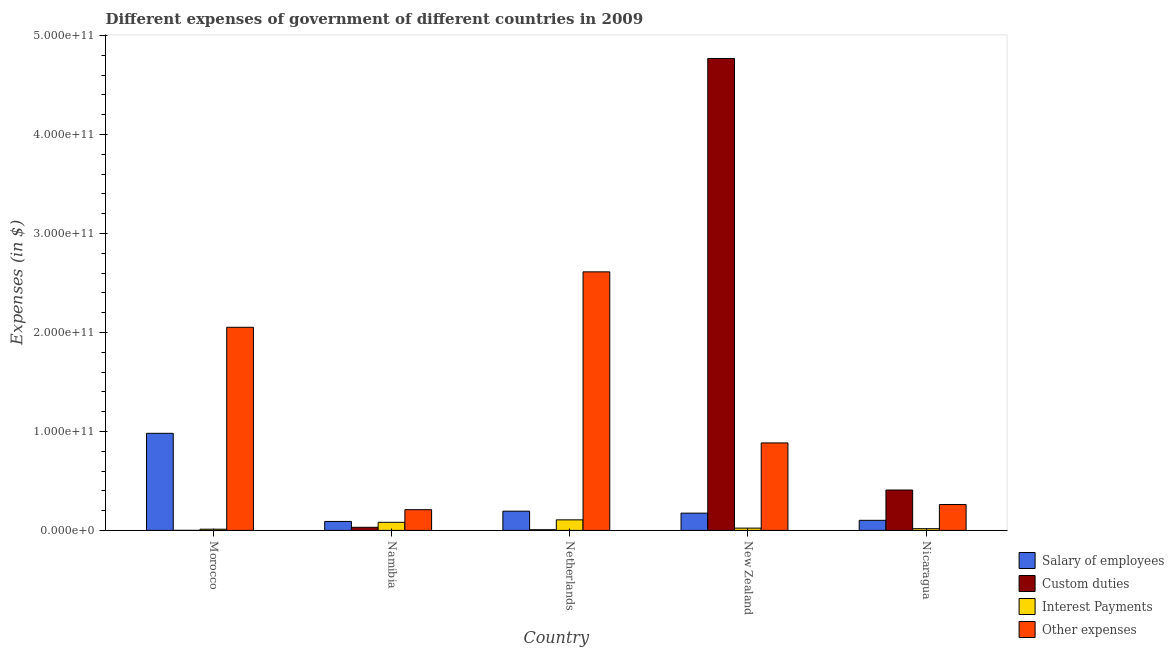How many different coloured bars are there?
Provide a short and direct response. 4. How many groups of bars are there?
Offer a terse response. 5. Are the number of bars per tick equal to the number of legend labels?
Keep it short and to the point. Yes. What is the label of the 2nd group of bars from the left?
Ensure brevity in your answer.  Namibia. In how many cases, is the number of bars for a given country not equal to the number of legend labels?
Give a very brief answer. 0. What is the amount spent on salary of employees in New Zealand?
Keep it short and to the point. 1.74e+1. Across all countries, what is the maximum amount spent on salary of employees?
Provide a succinct answer. 9.81e+1. Across all countries, what is the minimum amount spent on custom duties?
Keep it short and to the point. 9.90e+05. In which country was the amount spent on salary of employees maximum?
Provide a short and direct response. Morocco. In which country was the amount spent on other expenses minimum?
Offer a very short reply. Namibia. What is the total amount spent on custom duties in the graph?
Make the answer very short. 5.21e+11. What is the difference between the amount spent on custom duties in Netherlands and that in New Zealand?
Offer a terse response. -4.76e+11. What is the difference between the amount spent on other expenses in New Zealand and the amount spent on salary of employees in Namibia?
Keep it short and to the point. 7.93e+1. What is the average amount spent on other expenses per country?
Offer a very short reply. 1.20e+11. What is the difference between the amount spent on interest payments and amount spent on salary of employees in Netherlands?
Your answer should be very brief. -8.78e+09. What is the ratio of the amount spent on interest payments in Morocco to that in New Zealand?
Provide a short and direct response. 0.52. What is the difference between the highest and the second highest amount spent on interest payments?
Give a very brief answer. 2.49e+09. What is the difference between the highest and the lowest amount spent on interest payments?
Your answer should be compact. 9.45e+09. Is the sum of the amount spent on interest payments in Namibia and New Zealand greater than the maximum amount spent on other expenses across all countries?
Give a very brief answer. No. Is it the case that in every country, the sum of the amount spent on interest payments and amount spent on salary of employees is greater than the sum of amount spent on other expenses and amount spent on custom duties?
Your answer should be very brief. No. What does the 2nd bar from the left in Nicaragua represents?
Ensure brevity in your answer.  Custom duties. What does the 4th bar from the right in Nicaragua represents?
Offer a very short reply. Salary of employees. Are all the bars in the graph horizontal?
Provide a short and direct response. No. How many countries are there in the graph?
Offer a very short reply. 5. What is the difference between two consecutive major ticks on the Y-axis?
Your answer should be compact. 1.00e+11. Does the graph contain any zero values?
Your answer should be compact. No. Does the graph contain grids?
Your answer should be compact. No. Where does the legend appear in the graph?
Provide a succinct answer. Bottom right. How many legend labels are there?
Provide a succinct answer. 4. How are the legend labels stacked?
Give a very brief answer. Vertical. What is the title of the graph?
Make the answer very short. Different expenses of government of different countries in 2009. What is the label or title of the Y-axis?
Ensure brevity in your answer.  Expenses (in $). What is the Expenses (in $) of Salary of employees in Morocco?
Keep it short and to the point. 9.81e+1. What is the Expenses (in $) in Custom duties in Morocco?
Ensure brevity in your answer.  9.90e+05. What is the Expenses (in $) of Interest Payments in Morocco?
Offer a terse response. 1.20e+09. What is the Expenses (in $) in Other expenses in Morocco?
Offer a terse response. 2.05e+11. What is the Expenses (in $) of Salary of employees in Namibia?
Make the answer very short. 9.05e+09. What is the Expenses (in $) in Custom duties in Namibia?
Offer a very short reply. 3.11e+09. What is the Expenses (in $) in Interest Payments in Namibia?
Give a very brief answer. 8.15e+09. What is the Expenses (in $) of Other expenses in Namibia?
Your answer should be compact. 2.09e+1. What is the Expenses (in $) in Salary of employees in Netherlands?
Make the answer very short. 1.94e+1. What is the Expenses (in $) of Custom duties in Netherlands?
Your answer should be very brief. 6.50e+08. What is the Expenses (in $) of Interest Payments in Netherlands?
Give a very brief answer. 1.06e+1. What is the Expenses (in $) of Other expenses in Netherlands?
Ensure brevity in your answer.  2.61e+11. What is the Expenses (in $) in Salary of employees in New Zealand?
Your answer should be compact. 1.74e+1. What is the Expenses (in $) of Custom duties in New Zealand?
Offer a very short reply. 4.77e+11. What is the Expenses (in $) in Interest Payments in New Zealand?
Offer a very short reply. 2.30e+09. What is the Expenses (in $) of Other expenses in New Zealand?
Your answer should be very brief. 8.84e+1. What is the Expenses (in $) in Salary of employees in Nicaragua?
Keep it short and to the point. 1.02e+1. What is the Expenses (in $) in Custom duties in Nicaragua?
Offer a terse response. 4.08e+1. What is the Expenses (in $) in Interest Payments in Nicaragua?
Offer a very short reply. 1.71e+09. What is the Expenses (in $) of Other expenses in Nicaragua?
Provide a succinct answer. 2.62e+1. Across all countries, what is the maximum Expenses (in $) of Salary of employees?
Keep it short and to the point. 9.81e+1. Across all countries, what is the maximum Expenses (in $) in Custom duties?
Keep it short and to the point. 4.77e+11. Across all countries, what is the maximum Expenses (in $) of Interest Payments?
Your answer should be very brief. 1.06e+1. Across all countries, what is the maximum Expenses (in $) of Other expenses?
Your answer should be compact. 2.61e+11. Across all countries, what is the minimum Expenses (in $) in Salary of employees?
Make the answer very short. 9.05e+09. Across all countries, what is the minimum Expenses (in $) in Custom duties?
Give a very brief answer. 9.90e+05. Across all countries, what is the minimum Expenses (in $) in Interest Payments?
Your answer should be very brief. 1.20e+09. Across all countries, what is the minimum Expenses (in $) in Other expenses?
Offer a terse response. 2.09e+1. What is the total Expenses (in $) in Salary of employees in the graph?
Keep it short and to the point. 1.54e+11. What is the total Expenses (in $) in Custom duties in the graph?
Provide a short and direct response. 5.21e+11. What is the total Expenses (in $) of Interest Payments in the graph?
Your response must be concise. 2.40e+1. What is the total Expenses (in $) in Other expenses in the graph?
Keep it short and to the point. 6.02e+11. What is the difference between the Expenses (in $) of Salary of employees in Morocco and that in Namibia?
Keep it short and to the point. 8.90e+1. What is the difference between the Expenses (in $) of Custom duties in Morocco and that in Namibia?
Offer a very short reply. -3.11e+09. What is the difference between the Expenses (in $) of Interest Payments in Morocco and that in Namibia?
Provide a short and direct response. -6.96e+09. What is the difference between the Expenses (in $) in Other expenses in Morocco and that in Namibia?
Make the answer very short. 1.84e+11. What is the difference between the Expenses (in $) of Salary of employees in Morocco and that in Netherlands?
Your answer should be compact. 7.87e+1. What is the difference between the Expenses (in $) in Custom duties in Morocco and that in Netherlands?
Provide a short and direct response. -6.49e+08. What is the difference between the Expenses (in $) in Interest Payments in Morocco and that in Netherlands?
Offer a very short reply. -9.45e+09. What is the difference between the Expenses (in $) in Other expenses in Morocco and that in Netherlands?
Your answer should be very brief. -5.60e+1. What is the difference between the Expenses (in $) in Salary of employees in Morocco and that in New Zealand?
Offer a very short reply. 8.07e+1. What is the difference between the Expenses (in $) of Custom duties in Morocco and that in New Zealand?
Provide a short and direct response. -4.77e+11. What is the difference between the Expenses (in $) of Interest Payments in Morocco and that in New Zealand?
Ensure brevity in your answer.  -1.10e+09. What is the difference between the Expenses (in $) in Other expenses in Morocco and that in New Zealand?
Your response must be concise. 1.17e+11. What is the difference between the Expenses (in $) in Salary of employees in Morocco and that in Nicaragua?
Your answer should be very brief. 8.79e+1. What is the difference between the Expenses (in $) of Custom duties in Morocco and that in Nicaragua?
Give a very brief answer. -4.08e+1. What is the difference between the Expenses (in $) in Interest Payments in Morocco and that in Nicaragua?
Keep it short and to the point. -5.15e+08. What is the difference between the Expenses (in $) of Other expenses in Morocco and that in Nicaragua?
Keep it short and to the point. 1.79e+11. What is the difference between the Expenses (in $) of Salary of employees in Namibia and that in Netherlands?
Provide a succinct answer. -1.04e+1. What is the difference between the Expenses (in $) in Custom duties in Namibia and that in Netherlands?
Your answer should be very brief. 2.46e+09. What is the difference between the Expenses (in $) of Interest Payments in Namibia and that in Netherlands?
Your response must be concise. -2.49e+09. What is the difference between the Expenses (in $) in Other expenses in Namibia and that in Netherlands?
Give a very brief answer. -2.40e+11. What is the difference between the Expenses (in $) of Salary of employees in Namibia and that in New Zealand?
Offer a very short reply. -8.38e+09. What is the difference between the Expenses (in $) of Custom duties in Namibia and that in New Zealand?
Your answer should be compact. -4.74e+11. What is the difference between the Expenses (in $) of Interest Payments in Namibia and that in New Zealand?
Your answer should be compact. 5.86e+09. What is the difference between the Expenses (in $) in Other expenses in Namibia and that in New Zealand?
Provide a short and direct response. -6.74e+1. What is the difference between the Expenses (in $) in Salary of employees in Namibia and that in Nicaragua?
Your answer should be very brief. -1.13e+09. What is the difference between the Expenses (in $) in Custom duties in Namibia and that in Nicaragua?
Provide a succinct answer. -3.77e+1. What is the difference between the Expenses (in $) in Interest Payments in Namibia and that in Nicaragua?
Provide a succinct answer. 6.44e+09. What is the difference between the Expenses (in $) in Other expenses in Namibia and that in Nicaragua?
Your answer should be very brief. -5.23e+09. What is the difference between the Expenses (in $) of Salary of employees in Netherlands and that in New Zealand?
Offer a very short reply. 2.00e+09. What is the difference between the Expenses (in $) in Custom duties in Netherlands and that in New Zealand?
Offer a very short reply. -4.76e+11. What is the difference between the Expenses (in $) of Interest Payments in Netherlands and that in New Zealand?
Your answer should be very brief. 8.35e+09. What is the difference between the Expenses (in $) in Other expenses in Netherlands and that in New Zealand?
Offer a terse response. 1.73e+11. What is the difference between the Expenses (in $) of Salary of employees in Netherlands and that in Nicaragua?
Keep it short and to the point. 9.25e+09. What is the difference between the Expenses (in $) in Custom duties in Netherlands and that in Nicaragua?
Give a very brief answer. -4.01e+1. What is the difference between the Expenses (in $) of Interest Payments in Netherlands and that in Nicaragua?
Your answer should be compact. 8.93e+09. What is the difference between the Expenses (in $) of Other expenses in Netherlands and that in Nicaragua?
Make the answer very short. 2.35e+11. What is the difference between the Expenses (in $) of Salary of employees in New Zealand and that in Nicaragua?
Offer a terse response. 7.25e+09. What is the difference between the Expenses (in $) in Custom duties in New Zealand and that in Nicaragua?
Keep it short and to the point. 4.36e+11. What is the difference between the Expenses (in $) of Interest Payments in New Zealand and that in Nicaragua?
Provide a short and direct response. 5.85e+08. What is the difference between the Expenses (in $) in Other expenses in New Zealand and that in Nicaragua?
Provide a short and direct response. 6.22e+1. What is the difference between the Expenses (in $) of Salary of employees in Morocco and the Expenses (in $) of Custom duties in Namibia?
Provide a short and direct response. 9.50e+1. What is the difference between the Expenses (in $) of Salary of employees in Morocco and the Expenses (in $) of Interest Payments in Namibia?
Ensure brevity in your answer.  8.99e+1. What is the difference between the Expenses (in $) of Salary of employees in Morocco and the Expenses (in $) of Other expenses in Namibia?
Provide a short and direct response. 7.72e+1. What is the difference between the Expenses (in $) in Custom duties in Morocco and the Expenses (in $) in Interest Payments in Namibia?
Ensure brevity in your answer.  -8.15e+09. What is the difference between the Expenses (in $) of Custom duties in Morocco and the Expenses (in $) of Other expenses in Namibia?
Offer a terse response. -2.09e+1. What is the difference between the Expenses (in $) in Interest Payments in Morocco and the Expenses (in $) in Other expenses in Namibia?
Your answer should be very brief. -1.97e+1. What is the difference between the Expenses (in $) in Salary of employees in Morocco and the Expenses (in $) in Custom duties in Netherlands?
Ensure brevity in your answer.  9.74e+1. What is the difference between the Expenses (in $) of Salary of employees in Morocco and the Expenses (in $) of Interest Payments in Netherlands?
Offer a terse response. 8.74e+1. What is the difference between the Expenses (in $) of Salary of employees in Morocco and the Expenses (in $) of Other expenses in Netherlands?
Provide a succinct answer. -1.63e+11. What is the difference between the Expenses (in $) of Custom duties in Morocco and the Expenses (in $) of Interest Payments in Netherlands?
Keep it short and to the point. -1.06e+1. What is the difference between the Expenses (in $) of Custom duties in Morocco and the Expenses (in $) of Other expenses in Netherlands?
Your answer should be very brief. -2.61e+11. What is the difference between the Expenses (in $) in Interest Payments in Morocco and the Expenses (in $) in Other expenses in Netherlands?
Ensure brevity in your answer.  -2.60e+11. What is the difference between the Expenses (in $) in Salary of employees in Morocco and the Expenses (in $) in Custom duties in New Zealand?
Your answer should be compact. -3.79e+11. What is the difference between the Expenses (in $) in Salary of employees in Morocco and the Expenses (in $) in Interest Payments in New Zealand?
Ensure brevity in your answer.  9.58e+1. What is the difference between the Expenses (in $) of Salary of employees in Morocco and the Expenses (in $) of Other expenses in New Zealand?
Give a very brief answer. 9.72e+09. What is the difference between the Expenses (in $) of Custom duties in Morocco and the Expenses (in $) of Interest Payments in New Zealand?
Offer a very short reply. -2.30e+09. What is the difference between the Expenses (in $) of Custom duties in Morocco and the Expenses (in $) of Other expenses in New Zealand?
Offer a terse response. -8.84e+1. What is the difference between the Expenses (in $) of Interest Payments in Morocco and the Expenses (in $) of Other expenses in New Zealand?
Your answer should be compact. -8.72e+1. What is the difference between the Expenses (in $) of Salary of employees in Morocco and the Expenses (in $) of Custom duties in Nicaragua?
Your answer should be compact. 5.73e+1. What is the difference between the Expenses (in $) of Salary of employees in Morocco and the Expenses (in $) of Interest Payments in Nicaragua?
Offer a very short reply. 9.64e+1. What is the difference between the Expenses (in $) of Salary of employees in Morocco and the Expenses (in $) of Other expenses in Nicaragua?
Offer a very short reply. 7.19e+1. What is the difference between the Expenses (in $) of Custom duties in Morocco and the Expenses (in $) of Interest Payments in Nicaragua?
Your answer should be compact. -1.71e+09. What is the difference between the Expenses (in $) of Custom duties in Morocco and the Expenses (in $) of Other expenses in Nicaragua?
Your answer should be compact. -2.62e+1. What is the difference between the Expenses (in $) in Interest Payments in Morocco and the Expenses (in $) in Other expenses in Nicaragua?
Provide a succinct answer. -2.50e+1. What is the difference between the Expenses (in $) of Salary of employees in Namibia and the Expenses (in $) of Custom duties in Netherlands?
Ensure brevity in your answer.  8.39e+09. What is the difference between the Expenses (in $) in Salary of employees in Namibia and the Expenses (in $) in Interest Payments in Netherlands?
Keep it short and to the point. -1.60e+09. What is the difference between the Expenses (in $) of Salary of employees in Namibia and the Expenses (in $) of Other expenses in Netherlands?
Give a very brief answer. -2.52e+11. What is the difference between the Expenses (in $) of Custom duties in Namibia and the Expenses (in $) of Interest Payments in Netherlands?
Ensure brevity in your answer.  -7.53e+09. What is the difference between the Expenses (in $) in Custom duties in Namibia and the Expenses (in $) in Other expenses in Netherlands?
Give a very brief answer. -2.58e+11. What is the difference between the Expenses (in $) in Interest Payments in Namibia and the Expenses (in $) in Other expenses in Netherlands?
Make the answer very short. -2.53e+11. What is the difference between the Expenses (in $) of Salary of employees in Namibia and the Expenses (in $) of Custom duties in New Zealand?
Offer a very short reply. -4.68e+11. What is the difference between the Expenses (in $) of Salary of employees in Namibia and the Expenses (in $) of Interest Payments in New Zealand?
Your answer should be very brief. 6.75e+09. What is the difference between the Expenses (in $) of Salary of employees in Namibia and the Expenses (in $) of Other expenses in New Zealand?
Keep it short and to the point. -7.93e+1. What is the difference between the Expenses (in $) of Custom duties in Namibia and the Expenses (in $) of Interest Payments in New Zealand?
Make the answer very short. 8.17e+08. What is the difference between the Expenses (in $) of Custom duties in Namibia and the Expenses (in $) of Other expenses in New Zealand?
Provide a succinct answer. -8.52e+1. What is the difference between the Expenses (in $) of Interest Payments in Namibia and the Expenses (in $) of Other expenses in New Zealand?
Ensure brevity in your answer.  -8.02e+1. What is the difference between the Expenses (in $) in Salary of employees in Namibia and the Expenses (in $) in Custom duties in Nicaragua?
Your response must be concise. -3.17e+1. What is the difference between the Expenses (in $) in Salary of employees in Namibia and the Expenses (in $) in Interest Payments in Nicaragua?
Offer a very short reply. 7.33e+09. What is the difference between the Expenses (in $) in Salary of employees in Namibia and the Expenses (in $) in Other expenses in Nicaragua?
Offer a very short reply. -1.71e+1. What is the difference between the Expenses (in $) in Custom duties in Namibia and the Expenses (in $) in Interest Payments in Nicaragua?
Give a very brief answer. 1.40e+09. What is the difference between the Expenses (in $) in Custom duties in Namibia and the Expenses (in $) in Other expenses in Nicaragua?
Offer a very short reply. -2.30e+1. What is the difference between the Expenses (in $) in Interest Payments in Namibia and the Expenses (in $) in Other expenses in Nicaragua?
Provide a short and direct response. -1.80e+1. What is the difference between the Expenses (in $) of Salary of employees in Netherlands and the Expenses (in $) of Custom duties in New Zealand?
Provide a short and direct response. -4.57e+11. What is the difference between the Expenses (in $) of Salary of employees in Netherlands and the Expenses (in $) of Interest Payments in New Zealand?
Your response must be concise. 1.71e+1. What is the difference between the Expenses (in $) in Salary of employees in Netherlands and the Expenses (in $) in Other expenses in New Zealand?
Give a very brief answer. -6.89e+1. What is the difference between the Expenses (in $) in Custom duties in Netherlands and the Expenses (in $) in Interest Payments in New Zealand?
Keep it short and to the point. -1.65e+09. What is the difference between the Expenses (in $) in Custom duties in Netherlands and the Expenses (in $) in Other expenses in New Zealand?
Your answer should be very brief. -8.77e+1. What is the difference between the Expenses (in $) of Interest Payments in Netherlands and the Expenses (in $) of Other expenses in New Zealand?
Keep it short and to the point. -7.77e+1. What is the difference between the Expenses (in $) in Salary of employees in Netherlands and the Expenses (in $) in Custom duties in Nicaragua?
Your response must be concise. -2.14e+1. What is the difference between the Expenses (in $) of Salary of employees in Netherlands and the Expenses (in $) of Interest Payments in Nicaragua?
Provide a succinct answer. 1.77e+1. What is the difference between the Expenses (in $) of Salary of employees in Netherlands and the Expenses (in $) of Other expenses in Nicaragua?
Ensure brevity in your answer.  -6.73e+09. What is the difference between the Expenses (in $) of Custom duties in Netherlands and the Expenses (in $) of Interest Payments in Nicaragua?
Provide a succinct answer. -1.06e+09. What is the difference between the Expenses (in $) in Custom duties in Netherlands and the Expenses (in $) in Other expenses in Nicaragua?
Your answer should be very brief. -2.55e+1. What is the difference between the Expenses (in $) in Interest Payments in Netherlands and the Expenses (in $) in Other expenses in Nicaragua?
Your answer should be compact. -1.55e+1. What is the difference between the Expenses (in $) in Salary of employees in New Zealand and the Expenses (in $) in Custom duties in Nicaragua?
Your response must be concise. -2.34e+1. What is the difference between the Expenses (in $) of Salary of employees in New Zealand and the Expenses (in $) of Interest Payments in Nicaragua?
Keep it short and to the point. 1.57e+1. What is the difference between the Expenses (in $) of Salary of employees in New Zealand and the Expenses (in $) of Other expenses in Nicaragua?
Give a very brief answer. -8.73e+09. What is the difference between the Expenses (in $) of Custom duties in New Zealand and the Expenses (in $) of Interest Payments in Nicaragua?
Your answer should be very brief. 4.75e+11. What is the difference between the Expenses (in $) of Custom duties in New Zealand and the Expenses (in $) of Other expenses in Nicaragua?
Make the answer very short. 4.51e+11. What is the difference between the Expenses (in $) of Interest Payments in New Zealand and the Expenses (in $) of Other expenses in Nicaragua?
Keep it short and to the point. -2.39e+1. What is the average Expenses (in $) in Salary of employees per country?
Your answer should be compact. 3.08e+1. What is the average Expenses (in $) of Custom duties per country?
Offer a very short reply. 1.04e+11. What is the average Expenses (in $) in Interest Payments per country?
Provide a short and direct response. 4.80e+09. What is the average Expenses (in $) of Other expenses per country?
Offer a terse response. 1.20e+11. What is the difference between the Expenses (in $) in Salary of employees and Expenses (in $) in Custom duties in Morocco?
Ensure brevity in your answer.  9.81e+1. What is the difference between the Expenses (in $) in Salary of employees and Expenses (in $) in Interest Payments in Morocco?
Your answer should be compact. 9.69e+1. What is the difference between the Expenses (in $) of Salary of employees and Expenses (in $) of Other expenses in Morocco?
Make the answer very short. -1.07e+11. What is the difference between the Expenses (in $) of Custom duties and Expenses (in $) of Interest Payments in Morocco?
Ensure brevity in your answer.  -1.20e+09. What is the difference between the Expenses (in $) of Custom duties and Expenses (in $) of Other expenses in Morocco?
Offer a very short reply. -2.05e+11. What is the difference between the Expenses (in $) of Interest Payments and Expenses (in $) of Other expenses in Morocco?
Give a very brief answer. -2.04e+11. What is the difference between the Expenses (in $) of Salary of employees and Expenses (in $) of Custom duties in Namibia?
Make the answer very short. 5.93e+09. What is the difference between the Expenses (in $) of Salary of employees and Expenses (in $) of Interest Payments in Namibia?
Offer a very short reply. 8.91e+08. What is the difference between the Expenses (in $) of Salary of employees and Expenses (in $) of Other expenses in Namibia?
Keep it short and to the point. -1.19e+1. What is the difference between the Expenses (in $) of Custom duties and Expenses (in $) of Interest Payments in Namibia?
Provide a short and direct response. -5.04e+09. What is the difference between the Expenses (in $) in Custom duties and Expenses (in $) in Other expenses in Namibia?
Ensure brevity in your answer.  -1.78e+1. What is the difference between the Expenses (in $) of Interest Payments and Expenses (in $) of Other expenses in Namibia?
Provide a short and direct response. -1.28e+1. What is the difference between the Expenses (in $) of Salary of employees and Expenses (in $) of Custom duties in Netherlands?
Your answer should be compact. 1.88e+1. What is the difference between the Expenses (in $) in Salary of employees and Expenses (in $) in Interest Payments in Netherlands?
Your answer should be compact. 8.78e+09. What is the difference between the Expenses (in $) of Salary of employees and Expenses (in $) of Other expenses in Netherlands?
Offer a very short reply. -2.42e+11. What is the difference between the Expenses (in $) of Custom duties and Expenses (in $) of Interest Payments in Netherlands?
Your answer should be very brief. -9.99e+09. What is the difference between the Expenses (in $) in Custom duties and Expenses (in $) in Other expenses in Netherlands?
Make the answer very short. -2.61e+11. What is the difference between the Expenses (in $) of Interest Payments and Expenses (in $) of Other expenses in Netherlands?
Ensure brevity in your answer.  -2.51e+11. What is the difference between the Expenses (in $) in Salary of employees and Expenses (in $) in Custom duties in New Zealand?
Offer a very short reply. -4.59e+11. What is the difference between the Expenses (in $) of Salary of employees and Expenses (in $) of Interest Payments in New Zealand?
Ensure brevity in your answer.  1.51e+1. What is the difference between the Expenses (in $) in Salary of employees and Expenses (in $) in Other expenses in New Zealand?
Provide a short and direct response. -7.09e+1. What is the difference between the Expenses (in $) of Custom duties and Expenses (in $) of Interest Payments in New Zealand?
Your answer should be compact. 4.75e+11. What is the difference between the Expenses (in $) of Custom duties and Expenses (in $) of Other expenses in New Zealand?
Ensure brevity in your answer.  3.88e+11. What is the difference between the Expenses (in $) in Interest Payments and Expenses (in $) in Other expenses in New Zealand?
Make the answer very short. -8.61e+1. What is the difference between the Expenses (in $) of Salary of employees and Expenses (in $) of Custom duties in Nicaragua?
Give a very brief answer. -3.06e+1. What is the difference between the Expenses (in $) of Salary of employees and Expenses (in $) of Interest Payments in Nicaragua?
Ensure brevity in your answer.  8.47e+09. What is the difference between the Expenses (in $) of Salary of employees and Expenses (in $) of Other expenses in Nicaragua?
Ensure brevity in your answer.  -1.60e+1. What is the difference between the Expenses (in $) of Custom duties and Expenses (in $) of Interest Payments in Nicaragua?
Your answer should be compact. 3.91e+1. What is the difference between the Expenses (in $) of Custom duties and Expenses (in $) of Other expenses in Nicaragua?
Your answer should be compact. 1.46e+1. What is the difference between the Expenses (in $) in Interest Payments and Expenses (in $) in Other expenses in Nicaragua?
Offer a terse response. -2.44e+1. What is the ratio of the Expenses (in $) in Salary of employees in Morocco to that in Namibia?
Offer a very short reply. 10.84. What is the ratio of the Expenses (in $) of Custom duties in Morocco to that in Namibia?
Your answer should be compact. 0. What is the ratio of the Expenses (in $) of Interest Payments in Morocco to that in Namibia?
Give a very brief answer. 0.15. What is the ratio of the Expenses (in $) in Other expenses in Morocco to that in Namibia?
Keep it short and to the point. 9.81. What is the ratio of the Expenses (in $) of Salary of employees in Morocco to that in Netherlands?
Provide a succinct answer. 5.05. What is the ratio of the Expenses (in $) of Custom duties in Morocco to that in Netherlands?
Make the answer very short. 0. What is the ratio of the Expenses (in $) in Interest Payments in Morocco to that in Netherlands?
Provide a short and direct response. 0.11. What is the ratio of the Expenses (in $) in Other expenses in Morocco to that in Netherlands?
Provide a short and direct response. 0.79. What is the ratio of the Expenses (in $) of Salary of employees in Morocco to that in New Zealand?
Offer a terse response. 5.63. What is the ratio of the Expenses (in $) of Interest Payments in Morocco to that in New Zealand?
Your response must be concise. 0.52. What is the ratio of the Expenses (in $) in Other expenses in Morocco to that in New Zealand?
Your answer should be very brief. 2.32. What is the ratio of the Expenses (in $) of Salary of employees in Morocco to that in Nicaragua?
Your response must be concise. 9.64. What is the ratio of the Expenses (in $) of Interest Payments in Morocco to that in Nicaragua?
Your answer should be very brief. 0.7. What is the ratio of the Expenses (in $) of Other expenses in Morocco to that in Nicaragua?
Your response must be concise. 7.84. What is the ratio of the Expenses (in $) in Salary of employees in Namibia to that in Netherlands?
Provide a short and direct response. 0.47. What is the ratio of the Expenses (in $) in Custom duties in Namibia to that in Netherlands?
Keep it short and to the point. 4.79. What is the ratio of the Expenses (in $) of Interest Payments in Namibia to that in Netherlands?
Your answer should be compact. 0.77. What is the ratio of the Expenses (in $) in Other expenses in Namibia to that in Netherlands?
Provide a succinct answer. 0.08. What is the ratio of the Expenses (in $) of Salary of employees in Namibia to that in New Zealand?
Make the answer very short. 0.52. What is the ratio of the Expenses (in $) in Custom duties in Namibia to that in New Zealand?
Your response must be concise. 0.01. What is the ratio of the Expenses (in $) of Interest Payments in Namibia to that in New Zealand?
Give a very brief answer. 3.55. What is the ratio of the Expenses (in $) of Other expenses in Namibia to that in New Zealand?
Make the answer very short. 0.24. What is the ratio of the Expenses (in $) of Salary of employees in Namibia to that in Nicaragua?
Keep it short and to the point. 0.89. What is the ratio of the Expenses (in $) of Custom duties in Namibia to that in Nicaragua?
Keep it short and to the point. 0.08. What is the ratio of the Expenses (in $) in Interest Payments in Namibia to that in Nicaragua?
Provide a short and direct response. 4.76. What is the ratio of the Expenses (in $) of Other expenses in Namibia to that in Nicaragua?
Give a very brief answer. 0.8. What is the ratio of the Expenses (in $) of Salary of employees in Netherlands to that in New Zealand?
Your answer should be very brief. 1.11. What is the ratio of the Expenses (in $) of Custom duties in Netherlands to that in New Zealand?
Your response must be concise. 0. What is the ratio of the Expenses (in $) of Interest Payments in Netherlands to that in New Zealand?
Ensure brevity in your answer.  4.63. What is the ratio of the Expenses (in $) of Other expenses in Netherlands to that in New Zealand?
Provide a succinct answer. 2.96. What is the ratio of the Expenses (in $) in Salary of employees in Netherlands to that in Nicaragua?
Your answer should be compact. 1.91. What is the ratio of the Expenses (in $) of Custom duties in Netherlands to that in Nicaragua?
Offer a terse response. 0.02. What is the ratio of the Expenses (in $) of Interest Payments in Netherlands to that in Nicaragua?
Keep it short and to the point. 6.22. What is the ratio of the Expenses (in $) in Other expenses in Netherlands to that in Nicaragua?
Provide a short and direct response. 9.99. What is the ratio of the Expenses (in $) in Salary of employees in New Zealand to that in Nicaragua?
Give a very brief answer. 1.71. What is the ratio of the Expenses (in $) of Custom duties in New Zealand to that in Nicaragua?
Your response must be concise. 11.69. What is the ratio of the Expenses (in $) of Interest Payments in New Zealand to that in Nicaragua?
Provide a short and direct response. 1.34. What is the ratio of the Expenses (in $) of Other expenses in New Zealand to that in Nicaragua?
Your answer should be compact. 3.38. What is the difference between the highest and the second highest Expenses (in $) in Salary of employees?
Provide a succinct answer. 7.87e+1. What is the difference between the highest and the second highest Expenses (in $) of Custom duties?
Your answer should be compact. 4.36e+11. What is the difference between the highest and the second highest Expenses (in $) in Interest Payments?
Provide a succinct answer. 2.49e+09. What is the difference between the highest and the second highest Expenses (in $) of Other expenses?
Provide a short and direct response. 5.60e+1. What is the difference between the highest and the lowest Expenses (in $) of Salary of employees?
Your response must be concise. 8.90e+1. What is the difference between the highest and the lowest Expenses (in $) of Custom duties?
Your response must be concise. 4.77e+11. What is the difference between the highest and the lowest Expenses (in $) in Interest Payments?
Make the answer very short. 9.45e+09. What is the difference between the highest and the lowest Expenses (in $) of Other expenses?
Ensure brevity in your answer.  2.40e+11. 